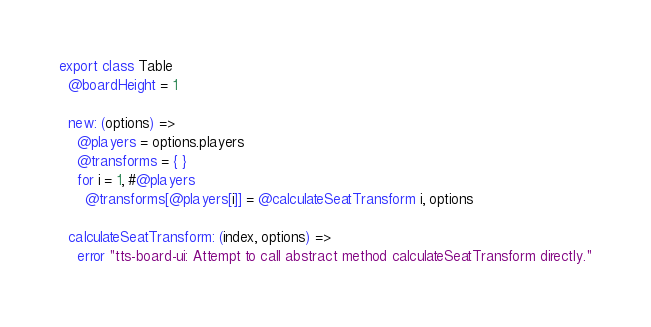<code> <loc_0><loc_0><loc_500><loc_500><_MoonScript_>export class Table
  @boardHeight = 1

  new: (options) =>
    @players = options.players
    @transforms = { }
    for i = 1, #@players
      @transforms[@players[i]] = @calculateSeatTransform i, options

  calculateSeatTransform: (index, options) =>
    error "tts-board-ui: Attempt to call abstract method calculateSeatTransform directly."
</code> 